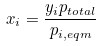Convert formula to latex. <formula><loc_0><loc_0><loc_500><loc_500>x _ { i } = \frac { y _ { i } p _ { t o t a l } } { p _ { i , e q m } }</formula> 